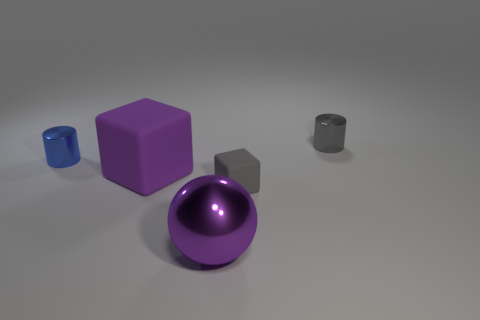How many metallic things are both to the left of the metallic ball and in front of the large purple matte cube?
Provide a short and direct response. 0. How many red objects are either shiny spheres or cylinders?
Provide a succinct answer. 0. How many matte things are either small gray cylinders or balls?
Offer a terse response. 0. Are any big green matte balls visible?
Your response must be concise. No. Do the blue metal thing and the small gray rubber thing have the same shape?
Your answer should be very brief. No. There is a tiny metal thing on the left side of the metallic cylinder that is behind the tiny blue thing; what number of tiny metallic cylinders are left of it?
Give a very brief answer. 0. There is a thing that is in front of the large purple rubber thing and behind the big sphere; what is its material?
Make the answer very short. Rubber. The metallic thing that is left of the small rubber block and behind the metal ball is what color?
Keep it short and to the point. Blue. Is there any other thing that is the same color as the ball?
Provide a succinct answer. Yes. What shape is the tiny gray object that is in front of the small metal cylinder in front of the small cylinder behind the blue metal object?
Provide a succinct answer. Cube. 